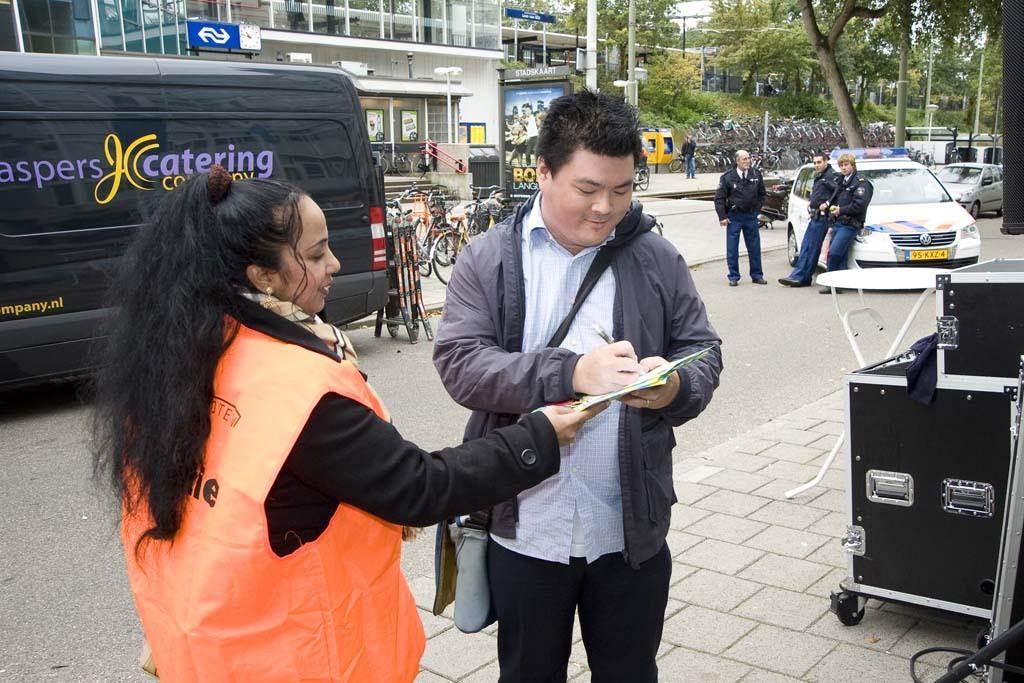In one or two sentences, can you explain what this image depicts? In this picture we can see a person writing on a paper. There is a woman holding a paper. We can see few vehicles and some people on the path. There is a building, few boards on the poles and some trees in the background. 